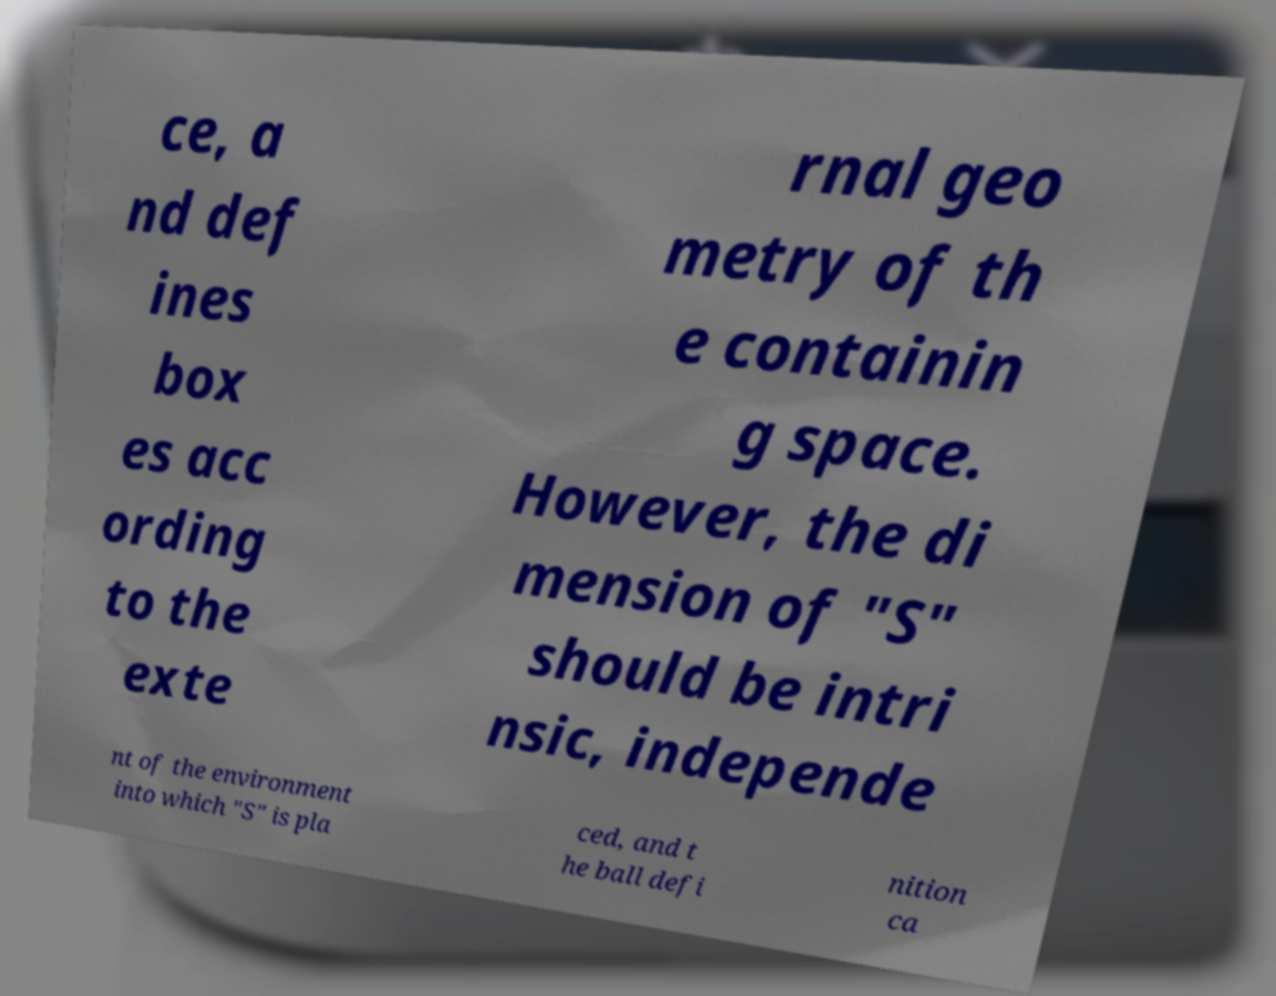Please read and relay the text visible in this image. What does it say? ce, a nd def ines box es acc ording to the exte rnal geo metry of th e containin g space. However, the di mension of "S" should be intri nsic, independe nt of the environment into which "S" is pla ced, and t he ball defi nition ca 